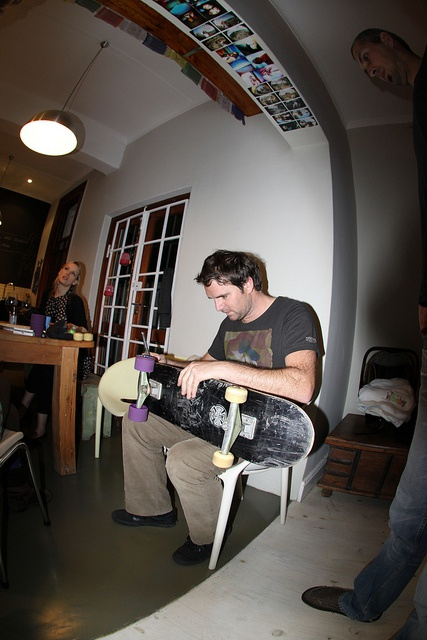Describe the objects in this image and their specific colors. I can see people in black, gray, and tan tones, skateboard in black, gray, darkgray, and lightgray tones, people in black tones, dining table in black, maroon, and brown tones, and people in black, maroon, and brown tones in this image. 